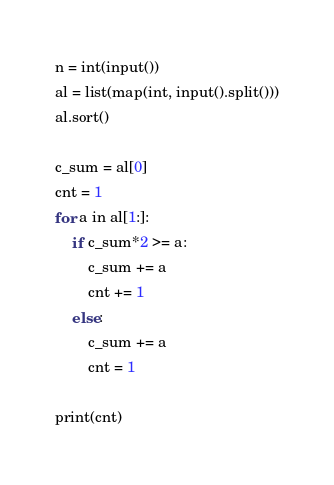<code> <loc_0><loc_0><loc_500><loc_500><_Python_>n = int(input())
al = list(map(int, input().split()))
al.sort()

c_sum = al[0]
cnt = 1
for a in al[1:]:
    if c_sum*2 >= a:
        c_sum += a
        cnt += 1
    else:
        c_sum += a
        cnt = 1

print(cnt)</code> 